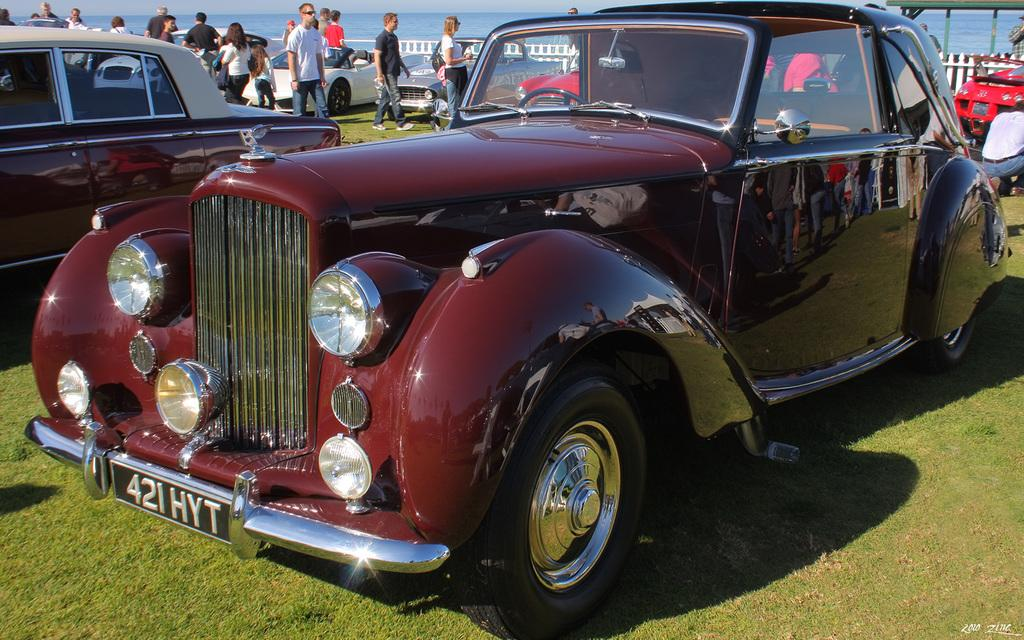What types of vehicles are in the image? There are different colors of cars in the image. What type of natural environment is visible in the image? There is grass visible in the image. Can you describe the people in the image? There is a group of people in the image. What type of barrier is present in the image? There is a fence in the image. What can be seen in the background of the image? There is water visible in the background of the image. What type of needle is being used by the company in the image? There is no company or needle present in the image. Can you tell me the color of the kitty playing with the cars in the image? There is no kitty present in the image. 